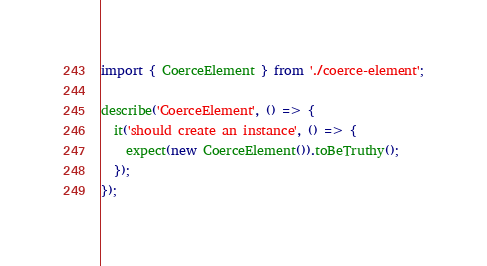Convert code to text. <code><loc_0><loc_0><loc_500><loc_500><_TypeScript_>import { CoerceElement } from './coerce-element';

describe('CoerceElement', () => {
  it('should create an instance', () => {
    expect(new CoerceElement()).toBeTruthy();
  });
});
</code> 